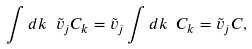Convert formula to latex. <formula><loc_0><loc_0><loc_500><loc_500>\int d { k } \ \tilde { v } _ { j } { C } _ { k } = \tilde { v } _ { j } \int d { k } \ { C } _ { k } = \tilde { v } _ { j } { C } ,</formula> 